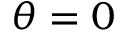Convert formula to latex. <formula><loc_0><loc_0><loc_500><loc_500>\theta = 0</formula> 